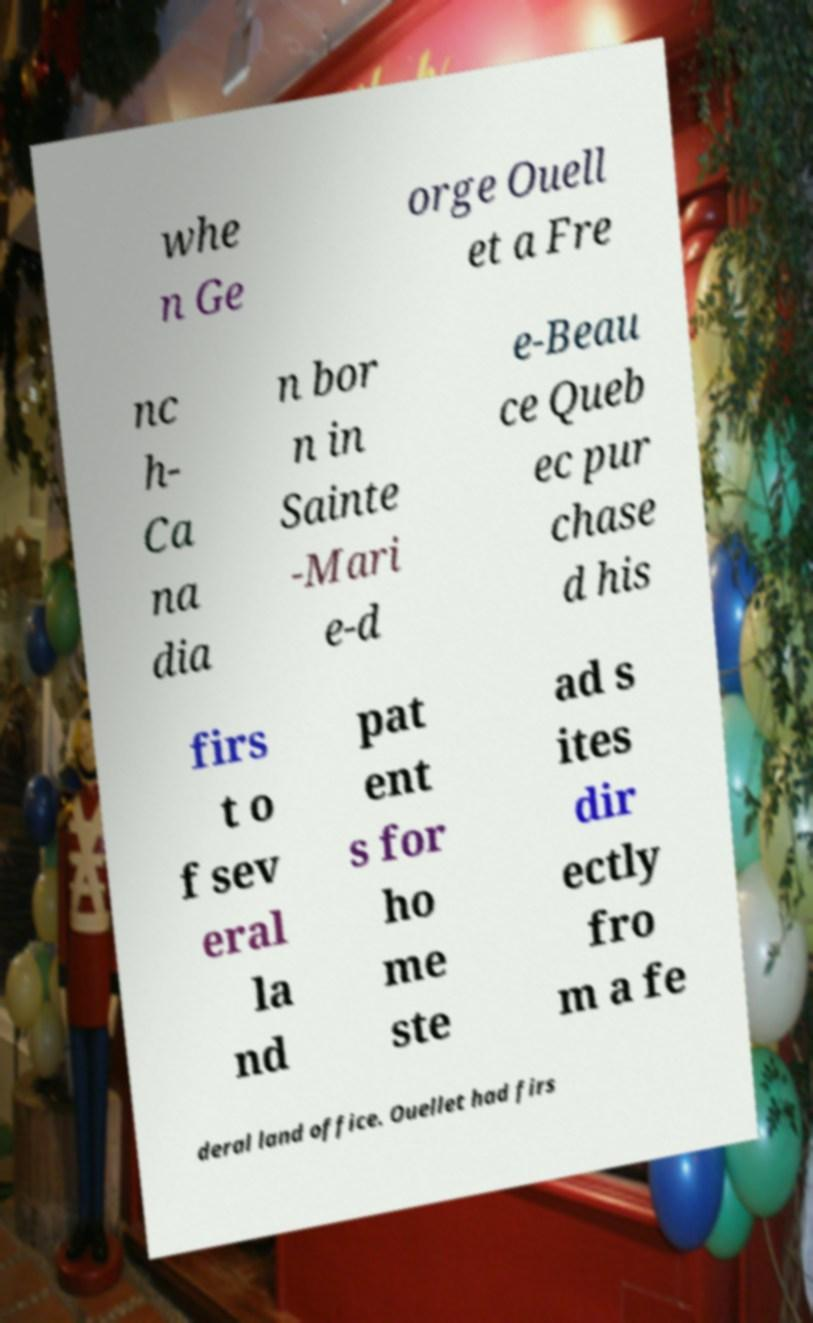Can you read and provide the text displayed in the image?This photo seems to have some interesting text. Can you extract and type it out for me? whe n Ge orge Ouell et a Fre nc h- Ca na dia n bor n in Sainte -Mari e-d e-Beau ce Queb ec pur chase d his firs t o f sev eral la nd pat ent s for ho me ste ad s ites dir ectly fro m a fe deral land office. Ouellet had firs 